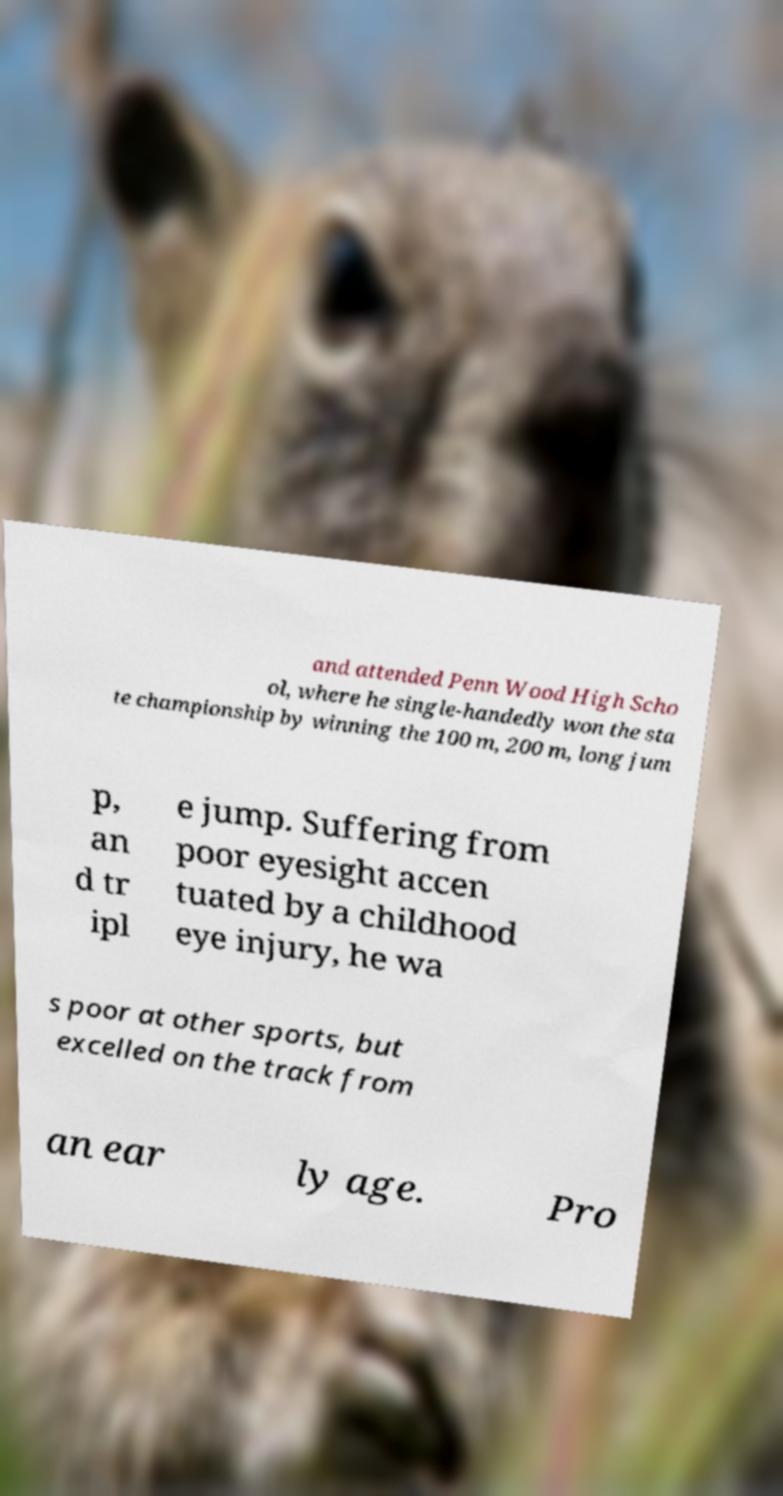Could you assist in decoding the text presented in this image and type it out clearly? and attended Penn Wood High Scho ol, where he single-handedly won the sta te championship by winning the 100 m, 200 m, long jum p, an d tr ipl e jump. Suffering from poor eyesight accen tuated by a childhood eye injury, he wa s poor at other sports, but excelled on the track from an ear ly age. Pro 